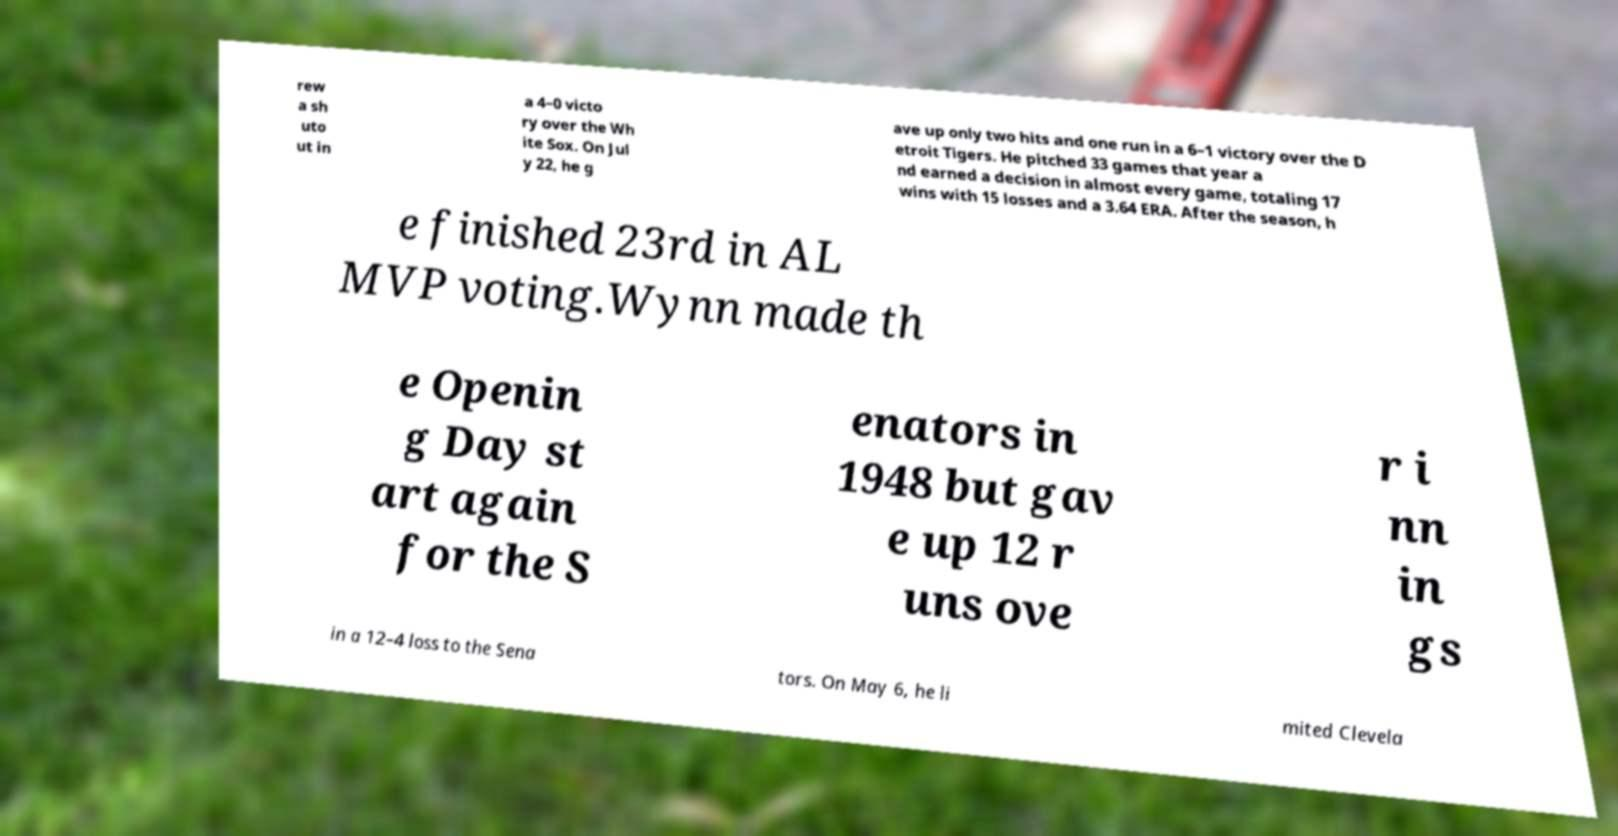For documentation purposes, I need the text within this image transcribed. Could you provide that? rew a sh uto ut in a 4–0 victo ry over the Wh ite Sox. On Jul y 22, he g ave up only two hits and one run in a 6–1 victory over the D etroit Tigers. He pitched 33 games that year a nd earned a decision in almost every game, totaling 17 wins with 15 losses and a 3.64 ERA. After the season, h e finished 23rd in AL MVP voting.Wynn made th e Openin g Day st art again for the S enators in 1948 but gav e up 12 r uns ove r i nn in gs in a 12–4 loss to the Sena tors. On May 6, he li mited Clevela 